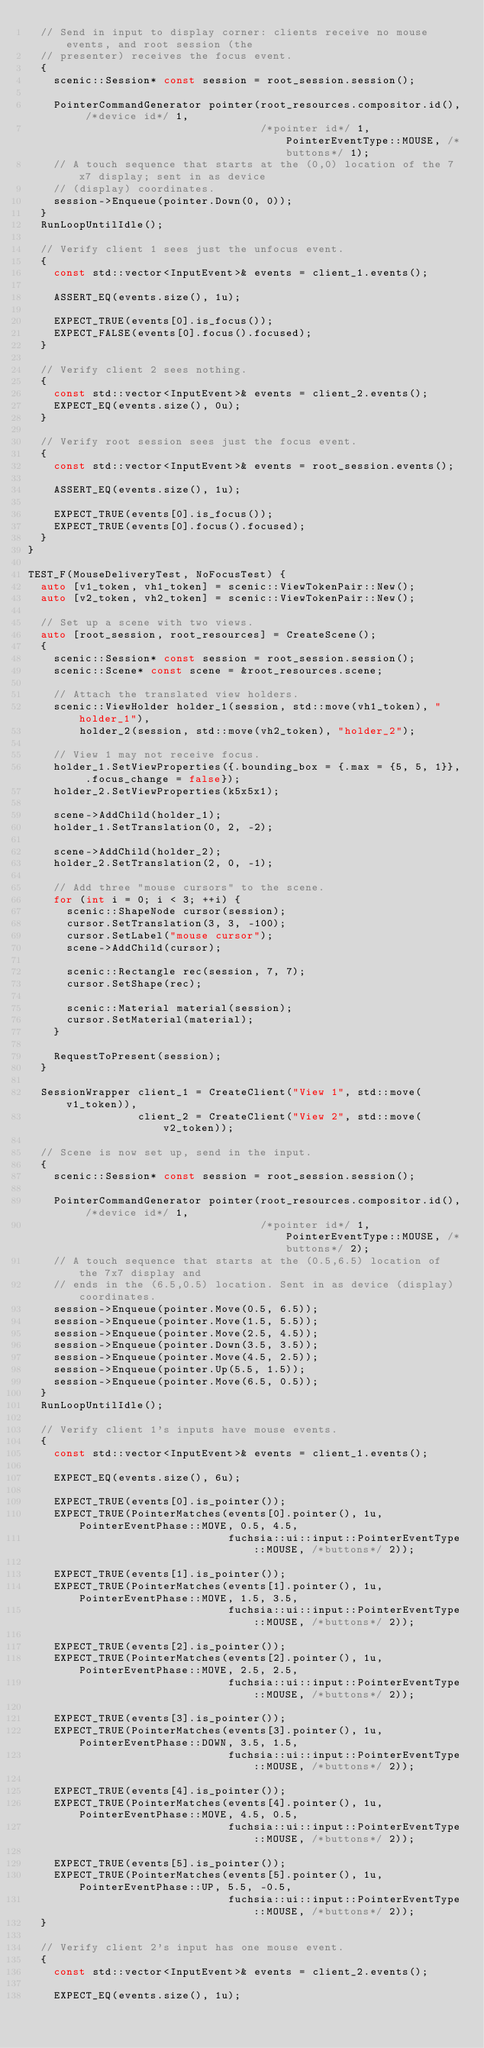Convert code to text. <code><loc_0><loc_0><loc_500><loc_500><_C++_>  // Send in input to display corner: clients receive no mouse events, and root session (the
  // presenter) receives the focus event.
  {
    scenic::Session* const session = root_session.session();

    PointerCommandGenerator pointer(root_resources.compositor.id(), /*device id*/ 1,
                                    /*pointer id*/ 1, PointerEventType::MOUSE, /*buttons*/ 1);
    // A touch sequence that starts at the (0,0) location of the 7x7 display; sent in as device
    // (display) coordinates.
    session->Enqueue(pointer.Down(0, 0));
  }
  RunLoopUntilIdle();

  // Verify client 1 sees just the unfocus event.
  {
    const std::vector<InputEvent>& events = client_1.events();

    ASSERT_EQ(events.size(), 1u);

    EXPECT_TRUE(events[0].is_focus());
    EXPECT_FALSE(events[0].focus().focused);
  }

  // Verify client 2 sees nothing.
  {
    const std::vector<InputEvent>& events = client_2.events();
    EXPECT_EQ(events.size(), 0u);
  }

  // Verify root session sees just the focus event.
  {
    const std::vector<InputEvent>& events = root_session.events();

    ASSERT_EQ(events.size(), 1u);

    EXPECT_TRUE(events[0].is_focus());
    EXPECT_TRUE(events[0].focus().focused);
  }
}

TEST_F(MouseDeliveryTest, NoFocusTest) {
  auto [v1_token, vh1_token] = scenic::ViewTokenPair::New();
  auto [v2_token, vh2_token] = scenic::ViewTokenPair::New();

  // Set up a scene with two views.
  auto [root_session, root_resources] = CreateScene();
  {
    scenic::Session* const session = root_session.session();
    scenic::Scene* const scene = &root_resources.scene;

    // Attach the translated view holders.
    scenic::ViewHolder holder_1(session, std::move(vh1_token), "holder_1"),
        holder_2(session, std::move(vh2_token), "holder_2");

    // View 1 may not receive focus.
    holder_1.SetViewProperties({.bounding_box = {.max = {5, 5, 1}}, .focus_change = false});
    holder_2.SetViewProperties(k5x5x1);

    scene->AddChild(holder_1);
    holder_1.SetTranslation(0, 2, -2);

    scene->AddChild(holder_2);
    holder_2.SetTranslation(2, 0, -1);

    // Add three "mouse cursors" to the scene.
    for (int i = 0; i < 3; ++i) {
      scenic::ShapeNode cursor(session);
      cursor.SetTranslation(3, 3, -100);
      cursor.SetLabel("mouse cursor");
      scene->AddChild(cursor);

      scenic::Rectangle rec(session, 7, 7);
      cursor.SetShape(rec);

      scenic::Material material(session);
      cursor.SetMaterial(material);
    }

    RequestToPresent(session);
  }

  SessionWrapper client_1 = CreateClient("View 1", std::move(v1_token)),
                 client_2 = CreateClient("View 2", std::move(v2_token));

  // Scene is now set up, send in the input.
  {
    scenic::Session* const session = root_session.session();

    PointerCommandGenerator pointer(root_resources.compositor.id(), /*device id*/ 1,
                                    /*pointer id*/ 1, PointerEventType::MOUSE, /*buttons*/ 2);
    // A touch sequence that starts at the (0.5,6.5) location of the 7x7 display and
    // ends in the (6.5,0.5) location. Sent in as device (display) coordinates.
    session->Enqueue(pointer.Move(0.5, 6.5));
    session->Enqueue(pointer.Move(1.5, 5.5));
    session->Enqueue(pointer.Move(2.5, 4.5));
    session->Enqueue(pointer.Down(3.5, 3.5));
    session->Enqueue(pointer.Move(4.5, 2.5));
    session->Enqueue(pointer.Up(5.5, 1.5));
    session->Enqueue(pointer.Move(6.5, 0.5));
  }
  RunLoopUntilIdle();

  // Verify client 1's inputs have mouse events.
  {
    const std::vector<InputEvent>& events = client_1.events();

    EXPECT_EQ(events.size(), 6u);

    EXPECT_TRUE(events[0].is_pointer());
    EXPECT_TRUE(PointerMatches(events[0].pointer(), 1u, PointerEventPhase::MOVE, 0.5, 4.5,
                               fuchsia::ui::input::PointerEventType::MOUSE, /*buttons*/ 2));

    EXPECT_TRUE(events[1].is_pointer());
    EXPECT_TRUE(PointerMatches(events[1].pointer(), 1u, PointerEventPhase::MOVE, 1.5, 3.5,
                               fuchsia::ui::input::PointerEventType::MOUSE, /*buttons*/ 2));

    EXPECT_TRUE(events[2].is_pointer());
    EXPECT_TRUE(PointerMatches(events[2].pointer(), 1u, PointerEventPhase::MOVE, 2.5, 2.5,
                               fuchsia::ui::input::PointerEventType::MOUSE, /*buttons*/ 2));

    EXPECT_TRUE(events[3].is_pointer());
    EXPECT_TRUE(PointerMatches(events[3].pointer(), 1u, PointerEventPhase::DOWN, 3.5, 1.5,
                               fuchsia::ui::input::PointerEventType::MOUSE, /*buttons*/ 2));

    EXPECT_TRUE(events[4].is_pointer());
    EXPECT_TRUE(PointerMatches(events[4].pointer(), 1u, PointerEventPhase::MOVE, 4.5, 0.5,
                               fuchsia::ui::input::PointerEventType::MOUSE, /*buttons*/ 2));

    EXPECT_TRUE(events[5].is_pointer());
    EXPECT_TRUE(PointerMatches(events[5].pointer(), 1u, PointerEventPhase::UP, 5.5, -0.5,
                               fuchsia::ui::input::PointerEventType::MOUSE, /*buttons*/ 2));
  }

  // Verify client 2's input has one mouse event.
  {
    const std::vector<InputEvent>& events = client_2.events();

    EXPECT_EQ(events.size(), 1u);
</code> 